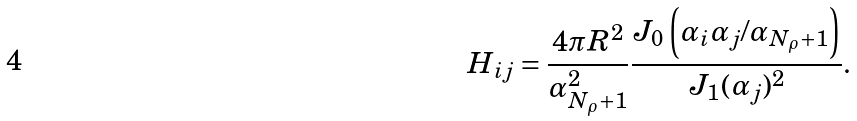<formula> <loc_0><loc_0><loc_500><loc_500>H _ { i j } = \frac { 4 \pi R ^ { 2 } } { \alpha _ { N _ { \rho } + 1 } ^ { 2 } } \frac { J _ { 0 } \left ( \alpha _ { i } \alpha _ { j } / \alpha _ { N _ { \rho } + 1 } \right ) } { J _ { 1 } ( \alpha _ { j } ) ^ { 2 } } .</formula> 